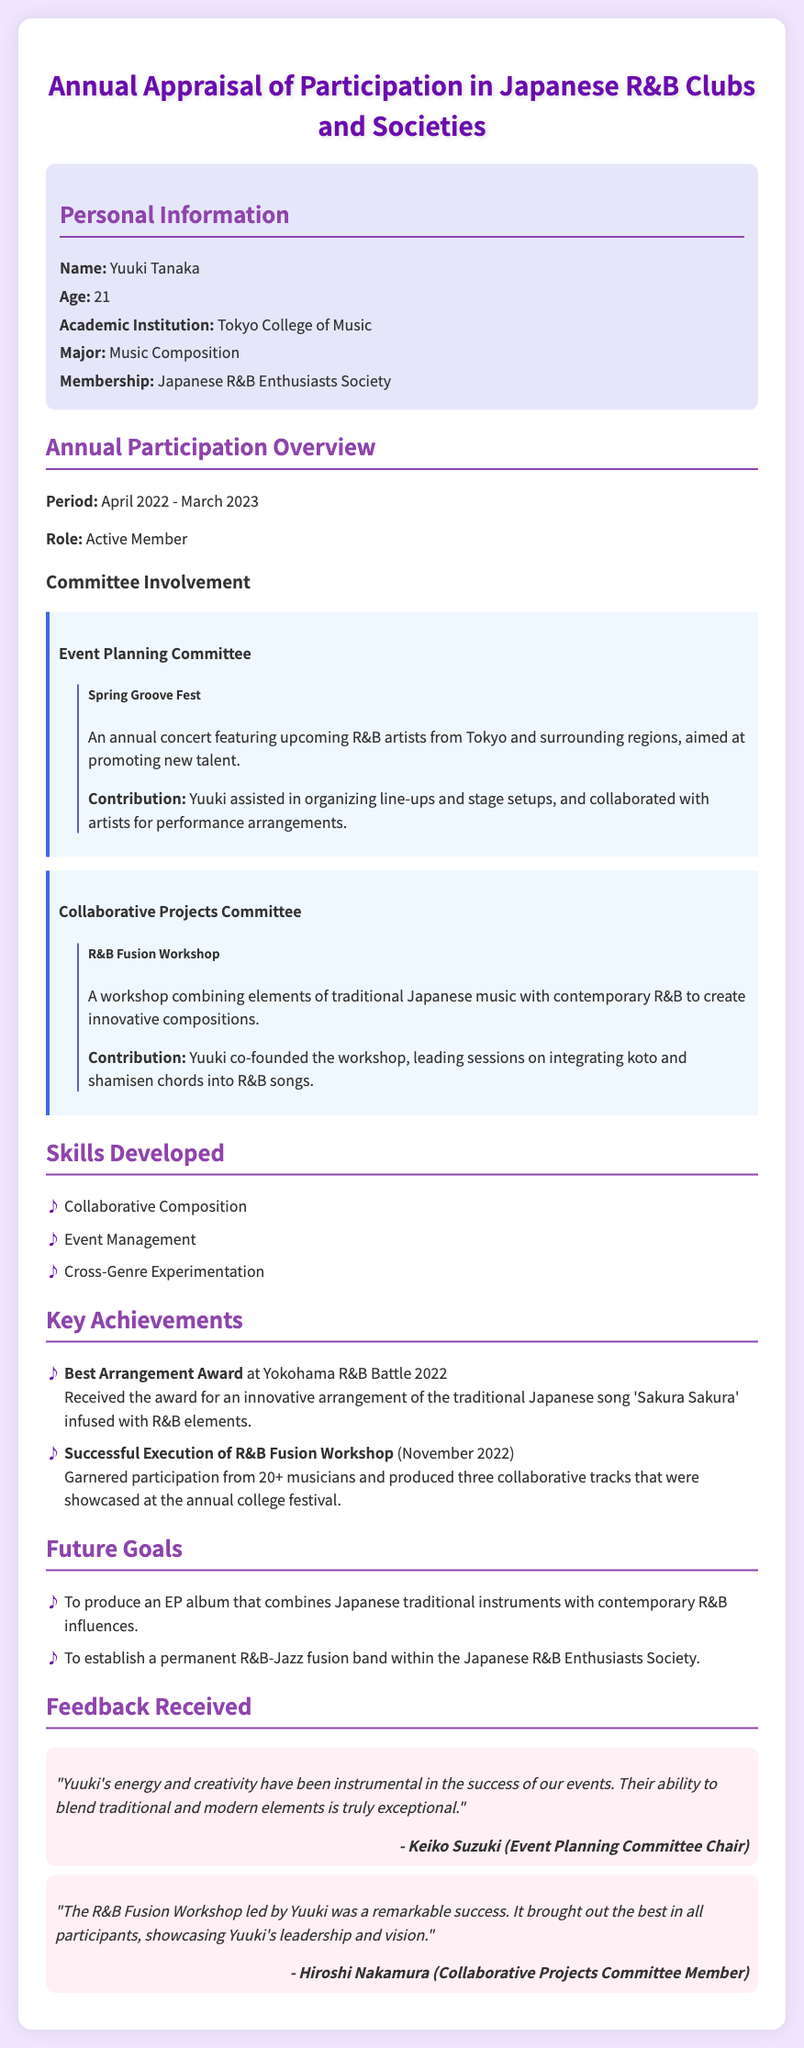what is the name of the individual being appraised? The name is listed in the personal information section of the document.
Answer: Yuuki Tanaka how old is Yuuki Tanaka? The age is stated under the personal information section.
Answer: 21 which academic institution does Yuuki attend? The academic institution is mentioned in the personal information section.
Answer: Tokyo College of Music what was the role of Yuuki in the club? The role is specified in the annual participation overview section.
Answer: Active Member what event did Yuuki assist with in the Event Planning Committee? The event is highlighted under the committee involvement section.
Answer: Spring Groove Fest what innovative workshop did Yuuki co-found? The workshop is detailed under Yuuki's contributions in the Collaborative Projects Committee.
Answer: R&B Fusion Workshop what award did Yuuki receive at the Yokohama R&B Battle 2022? The award is listed in the key achievements section.
Answer: Best Arrangement Award how many musicians participated in the R&B Fusion Workshop? The number of participants is mentioned in the key achievements section.
Answer: 20+ what is one of Yuuki's future goals regarding music? The future goals are expressed in the future goals section.
Answer: To produce an EP album that combines Japanese traditional instruments with contemporary R&B influences who provided feedback on Yuuki's contributions? The feedback section mentions individuals who commented on Yuuki’s work.
Answer: Keiko Suzuki and Hiroshi Nakamura 